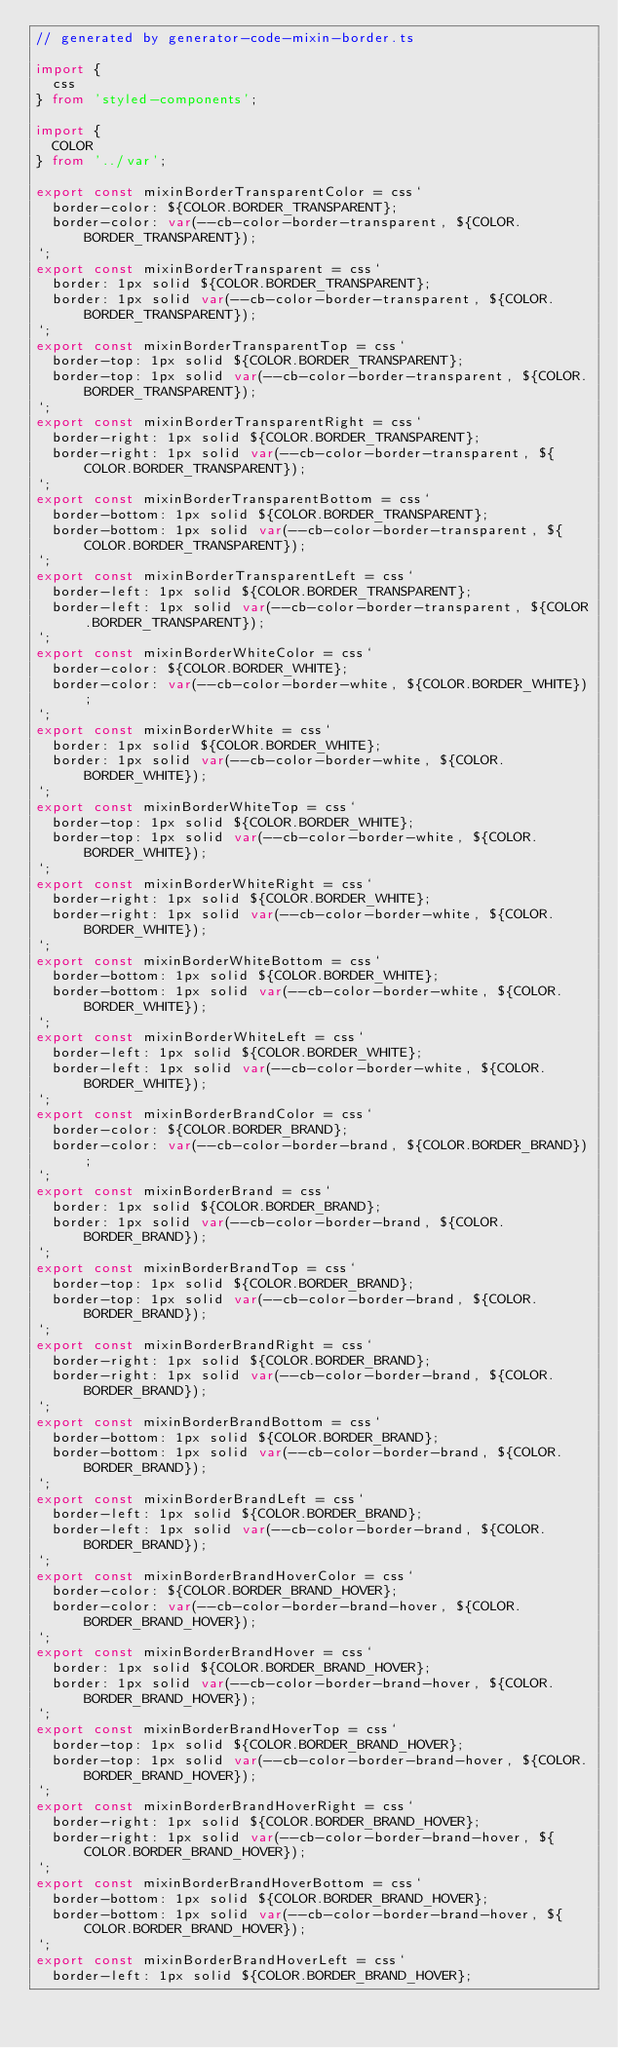Convert code to text. <code><loc_0><loc_0><loc_500><loc_500><_TypeScript_>// generated by generator-code-mixin-border.ts

import {
  css
} from 'styled-components';

import {
  COLOR
} from '../var';

export const mixinBorderTransparentColor = css`
  border-color: ${COLOR.BORDER_TRANSPARENT};
  border-color: var(--cb-color-border-transparent, ${COLOR.BORDER_TRANSPARENT});
`;
export const mixinBorderTransparent = css`
  border: 1px solid ${COLOR.BORDER_TRANSPARENT};
  border: 1px solid var(--cb-color-border-transparent, ${COLOR.BORDER_TRANSPARENT});
`;
export const mixinBorderTransparentTop = css`
  border-top: 1px solid ${COLOR.BORDER_TRANSPARENT};
  border-top: 1px solid var(--cb-color-border-transparent, ${COLOR.BORDER_TRANSPARENT});
`;
export const mixinBorderTransparentRight = css`
  border-right: 1px solid ${COLOR.BORDER_TRANSPARENT};
  border-right: 1px solid var(--cb-color-border-transparent, ${COLOR.BORDER_TRANSPARENT});
`;
export const mixinBorderTransparentBottom = css`
  border-bottom: 1px solid ${COLOR.BORDER_TRANSPARENT};
  border-bottom: 1px solid var(--cb-color-border-transparent, ${COLOR.BORDER_TRANSPARENT});
`;
export const mixinBorderTransparentLeft = css`
  border-left: 1px solid ${COLOR.BORDER_TRANSPARENT};
  border-left: 1px solid var(--cb-color-border-transparent, ${COLOR.BORDER_TRANSPARENT});
`;
export const mixinBorderWhiteColor = css`
  border-color: ${COLOR.BORDER_WHITE};
  border-color: var(--cb-color-border-white, ${COLOR.BORDER_WHITE});
`;
export const mixinBorderWhite = css`
  border: 1px solid ${COLOR.BORDER_WHITE};
  border: 1px solid var(--cb-color-border-white, ${COLOR.BORDER_WHITE});
`;
export const mixinBorderWhiteTop = css`
  border-top: 1px solid ${COLOR.BORDER_WHITE};
  border-top: 1px solid var(--cb-color-border-white, ${COLOR.BORDER_WHITE});
`;
export const mixinBorderWhiteRight = css`
  border-right: 1px solid ${COLOR.BORDER_WHITE};
  border-right: 1px solid var(--cb-color-border-white, ${COLOR.BORDER_WHITE});
`;
export const mixinBorderWhiteBottom = css`
  border-bottom: 1px solid ${COLOR.BORDER_WHITE};
  border-bottom: 1px solid var(--cb-color-border-white, ${COLOR.BORDER_WHITE});
`;
export const mixinBorderWhiteLeft = css`
  border-left: 1px solid ${COLOR.BORDER_WHITE};
  border-left: 1px solid var(--cb-color-border-white, ${COLOR.BORDER_WHITE});
`;
export const mixinBorderBrandColor = css`
  border-color: ${COLOR.BORDER_BRAND};
  border-color: var(--cb-color-border-brand, ${COLOR.BORDER_BRAND});
`;
export const mixinBorderBrand = css`
  border: 1px solid ${COLOR.BORDER_BRAND};
  border: 1px solid var(--cb-color-border-brand, ${COLOR.BORDER_BRAND});
`;
export const mixinBorderBrandTop = css`
  border-top: 1px solid ${COLOR.BORDER_BRAND};
  border-top: 1px solid var(--cb-color-border-brand, ${COLOR.BORDER_BRAND});
`;
export const mixinBorderBrandRight = css`
  border-right: 1px solid ${COLOR.BORDER_BRAND};
  border-right: 1px solid var(--cb-color-border-brand, ${COLOR.BORDER_BRAND});
`;
export const mixinBorderBrandBottom = css`
  border-bottom: 1px solid ${COLOR.BORDER_BRAND};
  border-bottom: 1px solid var(--cb-color-border-brand, ${COLOR.BORDER_BRAND});
`;
export const mixinBorderBrandLeft = css`
  border-left: 1px solid ${COLOR.BORDER_BRAND};
  border-left: 1px solid var(--cb-color-border-brand, ${COLOR.BORDER_BRAND});
`;
export const mixinBorderBrandHoverColor = css`
  border-color: ${COLOR.BORDER_BRAND_HOVER};
  border-color: var(--cb-color-border-brand-hover, ${COLOR.BORDER_BRAND_HOVER});
`;
export const mixinBorderBrandHover = css`
  border: 1px solid ${COLOR.BORDER_BRAND_HOVER};
  border: 1px solid var(--cb-color-border-brand-hover, ${COLOR.BORDER_BRAND_HOVER});
`;
export const mixinBorderBrandHoverTop = css`
  border-top: 1px solid ${COLOR.BORDER_BRAND_HOVER};
  border-top: 1px solid var(--cb-color-border-brand-hover, ${COLOR.BORDER_BRAND_HOVER});
`;
export const mixinBorderBrandHoverRight = css`
  border-right: 1px solid ${COLOR.BORDER_BRAND_HOVER};
  border-right: 1px solid var(--cb-color-border-brand-hover, ${COLOR.BORDER_BRAND_HOVER});
`;
export const mixinBorderBrandHoverBottom = css`
  border-bottom: 1px solid ${COLOR.BORDER_BRAND_HOVER};
  border-bottom: 1px solid var(--cb-color-border-brand-hover, ${COLOR.BORDER_BRAND_HOVER});
`;
export const mixinBorderBrandHoverLeft = css`
  border-left: 1px solid ${COLOR.BORDER_BRAND_HOVER};</code> 